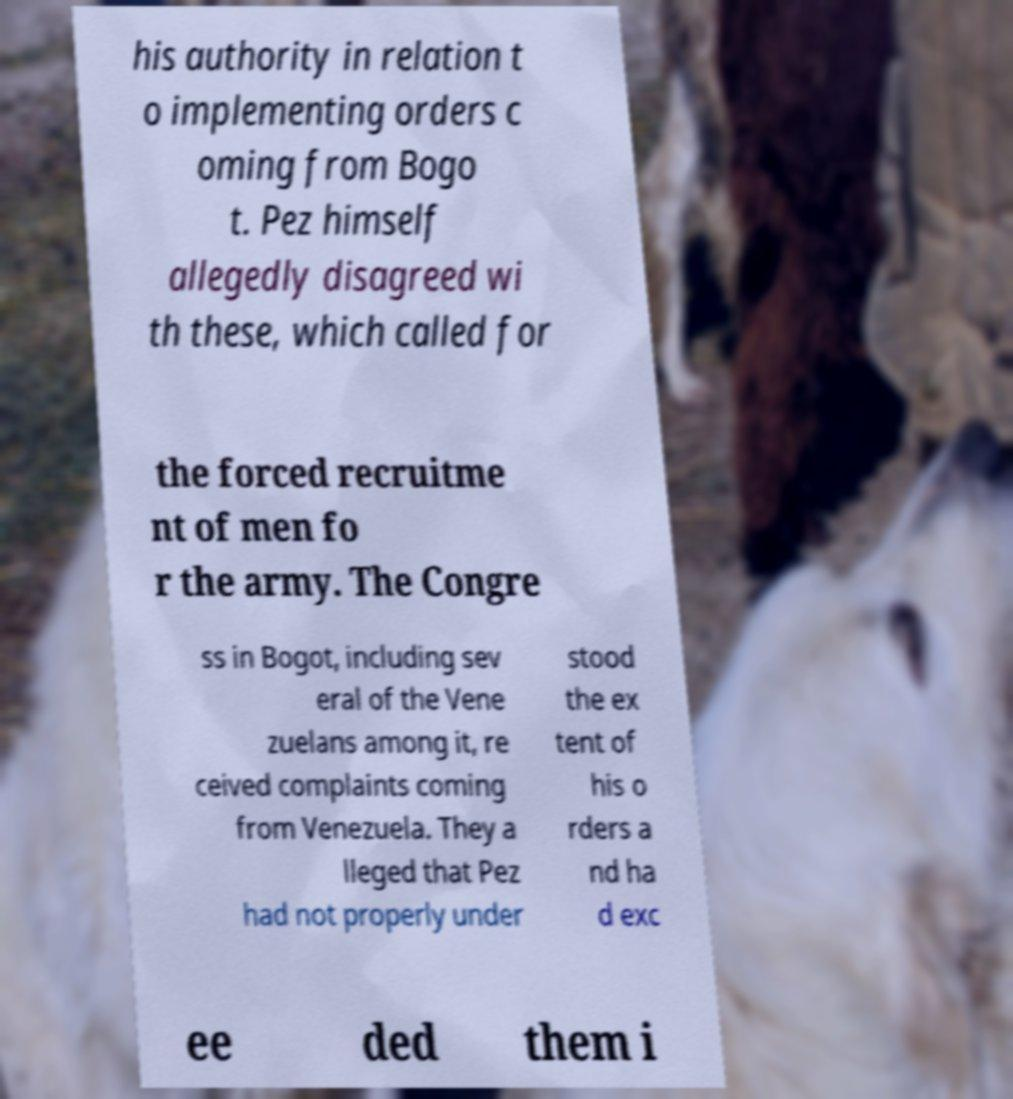For documentation purposes, I need the text within this image transcribed. Could you provide that? his authority in relation t o implementing orders c oming from Bogo t. Pez himself allegedly disagreed wi th these, which called for the forced recruitme nt of men fo r the army. The Congre ss in Bogot, including sev eral of the Vene zuelans among it, re ceived complaints coming from Venezuela. They a lleged that Pez had not properly under stood the ex tent of his o rders a nd ha d exc ee ded them i 